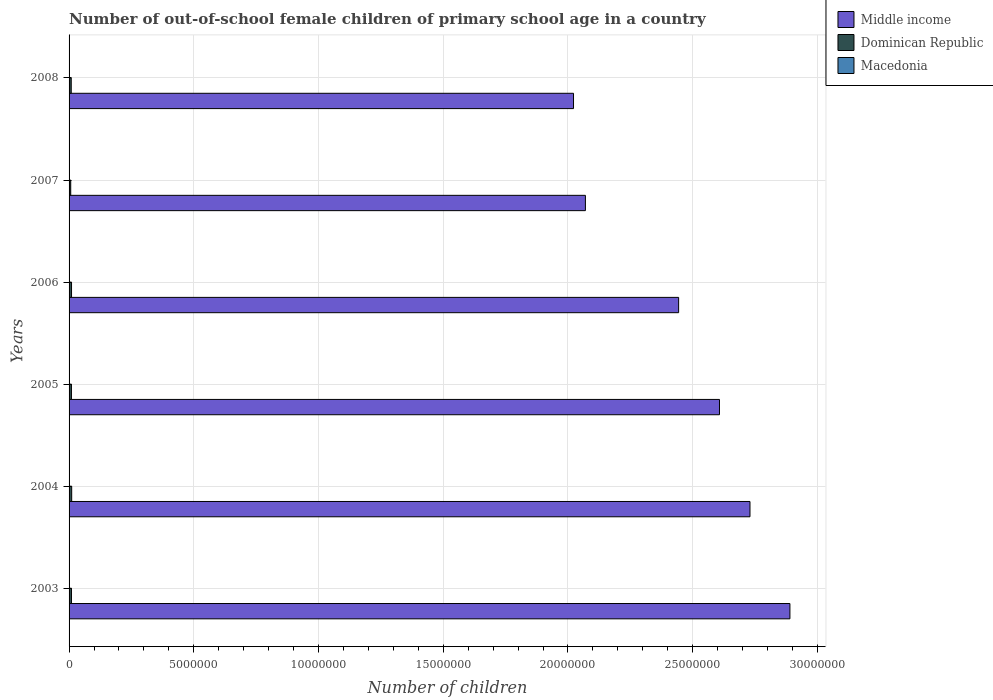How many bars are there on the 4th tick from the bottom?
Your response must be concise. 3. What is the label of the 5th group of bars from the top?
Offer a very short reply. 2004. What is the number of out-of-school female children in Middle income in 2003?
Provide a succinct answer. 2.89e+07. Across all years, what is the maximum number of out-of-school female children in Dominican Republic?
Your answer should be compact. 1.05e+05. Across all years, what is the minimum number of out-of-school female children in Dominican Republic?
Provide a short and direct response. 6.61e+04. In which year was the number of out-of-school female children in Middle income maximum?
Provide a succinct answer. 2003. What is the total number of out-of-school female children in Macedonia in the graph?
Offer a very short reply. 2.68e+04. What is the difference between the number of out-of-school female children in Dominican Republic in 2006 and that in 2008?
Your answer should be very brief. 1.19e+04. What is the difference between the number of out-of-school female children in Dominican Republic in 2006 and the number of out-of-school female children in Macedonia in 2007?
Offer a terse response. 9.52e+04. What is the average number of out-of-school female children in Middle income per year?
Provide a succinct answer. 2.46e+07. In the year 2004, what is the difference between the number of out-of-school female children in Macedonia and number of out-of-school female children in Middle income?
Offer a terse response. -2.73e+07. In how many years, is the number of out-of-school female children in Macedonia greater than 10000000 ?
Offer a terse response. 0. What is the ratio of the number of out-of-school female children in Dominican Republic in 2006 to that in 2007?
Keep it short and to the point. 1.5. Is the number of out-of-school female children in Dominican Republic in 2004 less than that in 2008?
Make the answer very short. No. What is the difference between the highest and the second highest number of out-of-school female children in Dominican Republic?
Your response must be concise. 6275. What is the difference between the highest and the lowest number of out-of-school female children in Dominican Republic?
Provide a succinct answer. 3.90e+04. In how many years, is the number of out-of-school female children in Middle income greater than the average number of out-of-school female children in Middle income taken over all years?
Provide a short and direct response. 3. Is the sum of the number of out-of-school female children in Dominican Republic in 2004 and 2007 greater than the maximum number of out-of-school female children in Macedonia across all years?
Your answer should be compact. Yes. What does the 1st bar from the top in 2008 represents?
Keep it short and to the point. Macedonia. What does the 2nd bar from the bottom in 2005 represents?
Offer a terse response. Dominican Republic. Does the graph contain grids?
Provide a succinct answer. Yes. How many legend labels are there?
Keep it short and to the point. 3. What is the title of the graph?
Provide a succinct answer. Number of out-of-school female children of primary school age in a country. Does "Tajikistan" appear as one of the legend labels in the graph?
Your answer should be compact. No. What is the label or title of the X-axis?
Ensure brevity in your answer.  Number of children. What is the Number of children of Middle income in 2003?
Give a very brief answer. 2.89e+07. What is the Number of children in Dominican Republic in 2003?
Make the answer very short. 9.59e+04. What is the Number of children of Macedonia in 2003?
Offer a very short reply. 5669. What is the Number of children of Middle income in 2004?
Keep it short and to the point. 2.73e+07. What is the Number of children in Dominican Republic in 2004?
Keep it short and to the point. 1.05e+05. What is the Number of children in Macedonia in 2004?
Your answer should be compact. 5037. What is the Number of children of Middle income in 2005?
Offer a very short reply. 2.61e+07. What is the Number of children of Dominican Republic in 2005?
Your answer should be very brief. 9.47e+04. What is the Number of children in Macedonia in 2005?
Provide a succinct answer. 4294. What is the Number of children of Middle income in 2006?
Provide a short and direct response. 2.44e+07. What is the Number of children of Dominican Republic in 2006?
Make the answer very short. 9.88e+04. What is the Number of children in Macedonia in 2006?
Give a very brief answer. 4150. What is the Number of children of Middle income in 2007?
Your response must be concise. 2.07e+07. What is the Number of children in Dominican Republic in 2007?
Give a very brief answer. 6.61e+04. What is the Number of children in Macedonia in 2007?
Your answer should be very brief. 3682. What is the Number of children in Middle income in 2008?
Offer a terse response. 2.02e+07. What is the Number of children of Dominican Republic in 2008?
Provide a short and direct response. 8.70e+04. What is the Number of children in Macedonia in 2008?
Ensure brevity in your answer.  3971. Across all years, what is the maximum Number of children of Middle income?
Provide a short and direct response. 2.89e+07. Across all years, what is the maximum Number of children of Dominican Republic?
Provide a succinct answer. 1.05e+05. Across all years, what is the maximum Number of children of Macedonia?
Ensure brevity in your answer.  5669. Across all years, what is the minimum Number of children of Middle income?
Keep it short and to the point. 2.02e+07. Across all years, what is the minimum Number of children of Dominican Republic?
Provide a short and direct response. 6.61e+04. Across all years, what is the minimum Number of children in Macedonia?
Your answer should be compact. 3682. What is the total Number of children of Middle income in the graph?
Your answer should be very brief. 1.48e+08. What is the total Number of children in Dominican Republic in the graph?
Your answer should be very brief. 5.48e+05. What is the total Number of children in Macedonia in the graph?
Provide a succinct answer. 2.68e+04. What is the difference between the Number of children in Middle income in 2003 and that in 2004?
Keep it short and to the point. 1.60e+06. What is the difference between the Number of children of Dominican Republic in 2003 and that in 2004?
Provide a succinct answer. -9225. What is the difference between the Number of children in Macedonia in 2003 and that in 2004?
Your answer should be compact. 632. What is the difference between the Number of children of Middle income in 2003 and that in 2005?
Give a very brief answer. 2.82e+06. What is the difference between the Number of children of Dominican Republic in 2003 and that in 2005?
Ensure brevity in your answer.  1151. What is the difference between the Number of children in Macedonia in 2003 and that in 2005?
Give a very brief answer. 1375. What is the difference between the Number of children in Middle income in 2003 and that in 2006?
Provide a short and direct response. 4.46e+06. What is the difference between the Number of children of Dominican Republic in 2003 and that in 2006?
Your response must be concise. -2950. What is the difference between the Number of children of Macedonia in 2003 and that in 2006?
Provide a succinct answer. 1519. What is the difference between the Number of children in Middle income in 2003 and that in 2007?
Your answer should be very brief. 8.20e+06. What is the difference between the Number of children of Dominican Republic in 2003 and that in 2007?
Make the answer very short. 2.98e+04. What is the difference between the Number of children in Macedonia in 2003 and that in 2007?
Provide a succinct answer. 1987. What is the difference between the Number of children of Middle income in 2003 and that in 2008?
Your answer should be compact. 8.67e+06. What is the difference between the Number of children in Dominican Republic in 2003 and that in 2008?
Keep it short and to the point. 8920. What is the difference between the Number of children of Macedonia in 2003 and that in 2008?
Offer a very short reply. 1698. What is the difference between the Number of children in Middle income in 2004 and that in 2005?
Your response must be concise. 1.22e+06. What is the difference between the Number of children in Dominican Republic in 2004 and that in 2005?
Offer a terse response. 1.04e+04. What is the difference between the Number of children of Macedonia in 2004 and that in 2005?
Offer a terse response. 743. What is the difference between the Number of children in Middle income in 2004 and that in 2006?
Your answer should be very brief. 2.86e+06. What is the difference between the Number of children of Dominican Republic in 2004 and that in 2006?
Provide a short and direct response. 6275. What is the difference between the Number of children in Macedonia in 2004 and that in 2006?
Your answer should be very brief. 887. What is the difference between the Number of children of Middle income in 2004 and that in 2007?
Give a very brief answer. 6.60e+06. What is the difference between the Number of children in Dominican Republic in 2004 and that in 2007?
Offer a terse response. 3.90e+04. What is the difference between the Number of children of Macedonia in 2004 and that in 2007?
Make the answer very short. 1355. What is the difference between the Number of children of Middle income in 2004 and that in 2008?
Ensure brevity in your answer.  7.07e+06. What is the difference between the Number of children of Dominican Republic in 2004 and that in 2008?
Your answer should be compact. 1.81e+04. What is the difference between the Number of children in Macedonia in 2004 and that in 2008?
Your answer should be compact. 1066. What is the difference between the Number of children in Middle income in 2005 and that in 2006?
Offer a very short reply. 1.64e+06. What is the difference between the Number of children of Dominican Republic in 2005 and that in 2006?
Offer a terse response. -4101. What is the difference between the Number of children in Macedonia in 2005 and that in 2006?
Your answer should be compact. 144. What is the difference between the Number of children of Middle income in 2005 and that in 2007?
Provide a succinct answer. 5.38e+06. What is the difference between the Number of children of Dominican Republic in 2005 and that in 2007?
Offer a very short reply. 2.87e+04. What is the difference between the Number of children in Macedonia in 2005 and that in 2007?
Offer a very short reply. 612. What is the difference between the Number of children of Middle income in 2005 and that in 2008?
Keep it short and to the point. 5.85e+06. What is the difference between the Number of children in Dominican Republic in 2005 and that in 2008?
Provide a short and direct response. 7769. What is the difference between the Number of children in Macedonia in 2005 and that in 2008?
Provide a short and direct response. 323. What is the difference between the Number of children in Middle income in 2006 and that in 2007?
Your response must be concise. 3.74e+06. What is the difference between the Number of children in Dominican Republic in 2006 and that in 2007?
Offer a terse response. 3.28e+04. What is the difference between the Number of children in Macedonia in 2006 and that in 2007?
Provide a short and direct response. 468. What is the difference between the Number of children in Middle income in 2006 and that in 2008?
Give a very brief answer. 4.21e+06. What is the difference between the Number of children in Dominican Republic in 2006 and that in 2008?
Your answer should be very brief. 1.19e+04. What is the difference between the Number of children of Macedonia in 2006 and that in 2008?
Offer a very short reply. 179. What is the difference between the Number of children in Middle income in 2007 and that in 2008?
Offer a terse response. 4.77e+05. What is the difference between the Number of children of Dominican Republic in 2007 and that in 2008?
Provide a succinct answer. -2.09e+04. What is the difference between the Number of children of Macedonia in 2007 and that in 2008?
Provide a short and direct response. -289. What is the difference between the Number of children in Middle income in 2003 and the Number of children in Dominican Republic in 2004?
Provide a succinct answer. 2.88e+07. What is the difference between the Number of children in Middle income in 2003 and the Number of children in Macedonia in 2004?
Provide a succinct answer. 2.89e+07. What is the difference between the Number of children in Dominican Republic in 2003 and the Number of children in Macedonia in 2004?
Give a very brief answer. 9.09e+04. What is the difference between the Number of children in Middle income in 2003 and the Number of children in Dominican Republic in 2005?
Ensure brevity in your answer.  2.88e+07. What is the difference between the Number of children of Middle income in 2003 and the Number of children of Macedonia in 2005?
Offer a terse response. 2.89e+07. What is the difference between the Number of children of Dominican Republic in 2003 and the Number of children of Macedonia in 2005?
Make the answer very short. 9.16e+04. What is the difference between the Number of children in Middle income in 2003 and the Number of children in Dominican Republic in 2006?
Provide a succinct answer. 2.88e+07. What is the difference between the Number of children of Middle income in 2003 and the Number of children of Macedonia in 2006?
Offer a terse response. 2.89e+07. What is the difference between the Number of children in Dominican Republic in 2003 and the Number of children in Macedonia in 2006?
Keep it short and to the point. 9.17e+04. What is the difference between the Number of children of Middle income in 2003 and the Number of children of Dominican Republic in 2007?
Your response must be concise. 2.88e+07. What is the difference between the Number of children of Middle income in 2003 and the Number of children of Macedonia in 2007?
Your response must be concise. 2.89e+07. What is the difference between the Number of children of Dominican Republic in 2003 and the Number of children of Macedonia in 2007?
Provide a succinct answer. 9.22e+04. What is the difference between the Number of children of Middle income in 2003 and the Number of children of Dominican Republic in 2008?
Keep it short and to the point. 2.88e+07. What is the difference between the Number of children in Middle income in 2003 and the Number of children in Macedonia in 2008?
Offer a very short reply. 2.89e+07. What is the difference between the Number of children of Dominican Republic in 2003 and the Number of children of Macedonia in 2008?
Offer a terse response. 9.19e+04. What is the difference between the Number of children in Middle income in 2004 and the Number of children in Dominican Republic in 2005?
Your answer should be compact. 2.72e+07. What is the difference between the Number of children of Middle income in 2004 and the Number of children of Macedonia in 2005?
Offer a terse response. 2.73e+07. What is the difference between the Number of children in Dominican Republic in 2004 and the Number of children in Macedonia in 2005?
Your answer should be very brief. 1.01e+05. What is the difference between the Number of children in Middle income in 2004 and the Number of children in Dominican Republic in 2006?
Make the answer very short. 2.72e+07. What is the difference between the Number of children of Middle income in 2004 and the Number of children of Macedonia in 2006?
Offer a very short reply. 2.73e+07. What is the difference between the Number of children in Dominican Republic in 2004 and the Number of children in Macedonia in 2006?
Provide a short and direct response. 1.01e+05. What is the difference between the Number of children in Middle income in 2004 and the Number of children in Dominican Republic in 2007?
Keep it short and to the point. 2.72e+07. What is the difference between the Number of children in Middle income in 2004 and the Number of children in Macedonia in 2007?
Your answer should be very brief. 2.73e+07. What is the difference between the Number of children in Dominican Republic in 2004 and the Number of children in Macedonia in 2007?
Your answer should be very brief. 1.01e+05. What is the difference between the Number of children in Middle income in 2004 and the Number of children in Dominican Republic in 2008?
Offer a very short reply. 2.72e+07. What is the difference between the Number of children of Middle income in 2004 and the Number of children of Macedonia in 2008?
Your response must be concise. 2.73e+07. What is the difference between the Number of children of Dominican Republic in 2004 and the Number of children of Macedonia in 2008?
Your answer should be compact. 1.01e+05. What is the difference between the Number of children of Middle income in 2005 and the Number of children of Dominican Republic in 2006?
Your answer should be very brief. 2.60e+07. What is the difference between the Number of children in Middle income in 2005 and the Number of children in Macedonia in 2006?
Your answer should be very brief. 2.61e+07. What is the difference between the Number of children in Dominican Republic in 2005 and the Number of children in Macedonia in 2006?
Ensure brevity in your answer.  9.06e+04. What is the difference between the Number of children of Middle income in 2005 and the Number of children of Dominican Republic in 2007?
Offer a terse response. 2.60e+07. What is the difference between the Number of children in Middle income in 2005 and the Number of children in Macedonia in 2007?
Provide a succinct answer. 2.61e+07. What is the difference between the Number of children in Dominican Republic in 2005 and the Number of children in Macedonia in 2007?
Provide a short and direct response. 9.11e+04. What is the difference between the Number of children in Middle income in 2005 and the Number of children in Dominican Republic in 2008?
Your answer should be very brief. 2.60e+07. What is the difference between the Number of children of Middle income in 2005 and the Number of children of Macedonia in 2008?
Your answer should be compact. 2.61e+07. What is the difference between the Number of children of Dominican Republic in 2005 and the Number of children of Macedonia in 2008?
Keep it short and to the point. 9.08e+04. What is the difference between the Number of children in Middle income in 2006 and the Number of children in Dominican Republic in 2007?
Your answer should be very brief. 2.44e+07. What is the difference between the Number of children of Middle income in 2006 and the Number of children of Macedonia in 2007?
Ensure brevity in your answer.  2.44e+07. What is the difference between the Number of children of Dominican Republic in 2006 and the Number of children of Macedonia in 2007?
Provide a succinct answer. 9.52e+04. What is the difference between the Number of children of Middle income in 2006 and the Number of children of Dominican Republic in 2008?
Make the answer very short. 2.43e+07. What is the difference between the Number of children of Middle income in 2006 and the Number of children of Macedonia in 2008?
Make the answer very short. 2.44e+07. What is the difference between the Number of children of Dominican Republic in 2006 and the Number of children of Macedonia in 2008?
Offer a terse response. 9.49e+04. What is the difference between the Number of children in Middle income in 2007 and the Number of children in Dominican Republic in 2008?
Ensure brevity in your answer.  2.06e+07. What is the difference between the Number of children of Middle income in 2007 and the Number of children of Macedonia in 2008?
Offer a very short reply. 2.07e+07. What is the difference between the Number of children of Dominican Republic in 2007 and the Number of children of Macedonia in 2008?
Your answer should be compact. 6.21e+04. What is the average Number of children in Middle income per year?
Your answer should be compact. 2.46e+07. What is the average Number of children in Dominican Republic per year?
Ensure brevity in your answer.  9.13e+04. What is the average Number of children in Macedonia per year?
Keep it short and to the point. 4467.17. In the year 2003, what is the difference between the Number of children in Middle income and Number of children in Dominican Republic?
Provide a short and direct response. 2.88e+07. In the year 2003, what is the difference between the Number of children in Middle income and Number of children in Macedonia?
Give a very brief answer. 2.89e+07. In the year 2003, what is the difference between the Number of children in Dominican Republic and Number of children in Macedonia?
Provide a short and direct response. 9.02e+04. In the year 2004, what is the difference between the Number of children in Middle income and Number of children in Dominican Republic?
Your answer should be compact. 2.72e+07. In the year 2004, what is the difference between the Number of children in Middle income and Number of children in Macedonia?
Your answer should be compact. 2.73e+07. In the year 2004, what is the difference between the Number of children in Dominican Republic and Number of children in Macedonia?
Your answer should be compact. 1.00e+05. In the year 2005, what is the difference between the Number of children in Middle income and Number of children in Dominican Republic?
Ensure brevity in your answer.  2.60e+07. In the year 2005, what is the difference between the Number of children in Middle income and Number of children in Macedonia?
Your answer should be very brief. 2.61e+07. In the year 2005, what is the difference between the Number of children of Dominican Republic and Number of children of Macedonia?
Offer a very short reply. 9.04e+04. In the year 2006, what is the difference between the Number of children in Middle income and Number of children in Dominican Republic?
Offer a very short reply. 2.43e+07. In the year 2006, what is the difference between the Number of children of Middle income and Number of children of Macedonia?
Provide a short and direct response. 2.44e+07. In the year 2006, what is the difference between the Number of children in Dominican Republic and Number of children in Macedonia?
Your response must be concise. 9.47e+04. In the year 2007, what is the difference between the Number of children in Middle income and Number of children in Dominican Republic?
Your response must be concise. 2.06e+07. In the year 2007, what is the difference between the Number of children in Middle income and Number of children in Macedonia?
Give a very brief answer. 2.07e+07. In the year 2007, what is the difference between the Number of children in Dominican Republic and Number of children in Macedonia?
Provide a short and direct response. 6.24e+04. In the year 2008, what is the difference between the Number of children in Middle income and Number of children in Dominican Republic?
Offer a terse response. 2.01e+07. In the year 2008, what is the difference between the Number of children of Middle income and Number of children of Macedonia?
Make the answer very short. 2.02e+07. In the year 2008, what is the difference between the Number of children of Dominican Republic and Number of children of Macedonia?
Provide a short and direct response. 8.30e+04. What is the ratio of the Number of children of Middle income in 2003 to that in 2004?
Your answer should be compact. 1.06. What is the ratio of the Number of children of Dominican Republic in 2003 to that in 2004?
Your answer should be very brief. 0.91. What is the ratio of the Number of children of Macedonia in 2003 to that in 2004?
Make the answer very short. 1.13. What is the ratio of the Number of children of Middle income in 2003 to that in 2005?
Offer a very short reply. 1.11. What is the ratio of the Number of children of Dominican Republic in 2003 to that in 2005?
Offer a terse response. 1.01. What is the ratio of the Number of children in Macedonia in 2003 to that in 2005?
Make the answer very short. 1.32. What is the ratio of the Number of children in Middle income in 2003 to that in 2006?
Your answer should be very brief. 1.18. What is the ratio of the Number of children in Dominican Republic in 2003 to that in 2006?
Give a very brief answer. 0.97. What is the ratio of the Number of children in Macedonia in 2003 to that in 2006?
Make the answer very short. 1.37. What is the ratio of the Number of children of Middle income in 2003 to that in 2007?
Your response must be concise. 1.4. What is the ratio of the Number of children of Dominican Republic in 2003 to that in 2007?
Make the answer very short. 1.45. What is the ratio of the Number of children of Macedonia in 2003 to that in 2007?
Your answer should be compact. 1.54. What is the ratio of the Number of children in Middle income in 2003 to that in 2008?
Give a very brief answer. 1.43. What is the ratio of the Number of children of Dominican Republic in 2003 to that in 2008?
Keep it short and to the point. 1.1. What is the ratio of the Number of children in Macedonia in 2003 to that in 2008?
Ensure brevity in your answer.  1.43. What is the ratio of the Number of children in Middle income in 2004 to that in 2005?
Your answer should be compact. 1.05. What is the ratio of the Number of children of Dominican Republic in 2004 to that in 2005?
Make the answer very short. 1.11. What is the ratio of the Number of children of Macedonia in 2004 to that in 2005?
Make the answer very short. 1.17. What is the ratio of the Number of children of Middle income in 2004 to that in 2006?
Provide a succinct answer. 1.12. What is the ratio of the Number of children of Dominican Republic in 2004 to that in 2006?
Your answer should be very brief. 1.06. What is the ratio of the Number of children of Macedonia in 2004 to that in 2006?
Offer a terse response. 1.21. What is the ratio of the Number of children of Middle income in 2004 to that in 2007?
Give a very brief answer. 1.32. What is the ratio of the Number of children in Dominican Republic in 2004 to that in 2007?
Offer a terse response. 1.59. What is the ratio of the Number of children of Macedonia in 2004 to that in 2007?
Your response must be concise. 1.37. What is the ratio of the Number of children of Middle income in 2004 to that in 2008?
Your response must be concise. 1.35. What is the ratio of the Number of children of Dominican Republic in 2004 to that in 2008?
Keep it short and to the point. 1.21. What is the ratio of the Number of children of Macedonia in 2004 to that in 2008?
Keep it short and to the point. 1.27. What is the ratio of the Number of children of Middle income in 2005 to that in 2006?
Offer a very short reply. 1.07. What is the ratio of the Number of children of Dominican Republic in 2005 to that in 2006?
Your answer should be very brief. 0.96. What is the ratio of the Number of children of Macedonia in 2005 to that in 2006?
Provide a short and direct response. 1.03. What is the ratio of the Number of children in Middle income in 2005 to that in 2007?
Offer a terse response. 1.26. What is the ratio of the Number of children in Dominican Republic in 2005 to that in 2007?
Give a very brief answer. 1.43. What is the ratio of the Number of children in Macedonia in 2005 to that in 2007?
Give a very brief answer. 1.17. What is the ratio of the Number of children in Middle income in 2005 to that in 2008?
Your response must be concise. 1.29. What is the ratio of the Number of children of Dominican Republic in 2005 to that in 2008?
Offer a very short reply. 1.09. What is the ratio of the Number of children of Macedonia in 2005 to that in 2008?
Give a very brief answer. 1.08. What is the ratio of the Number of children in Middle income in 2006 to that in 2007?
Offer a very short reply. 1.18. What is the ratio of the Number of children of Dominican Republic in 2006 to that in 2007?
Give a very brief answer. 1.5. What is the ratio of the Number of children of Macedonia in 2006 to that in 2007?
Your answer should be very brief. 1.13. What is the ratio of the Number of children of Middle income in 2006 to that in 2008?
Your answer should be very brief. 1.21. What is the ratio of the Number of children of Dominican Republic in 2006 to that in 2008?
Offer a very short reply. 1.14. What is the ratio of the Number of children in Macedonia in 2006 to that in 2008?
Provide a succinct answer. 1.05. What is the ratio of the Number of children in Middle income in 2007 to that in 2008?
Provide a succinct answer. 1.02. What is the ratio of the Number of children in Dominican Republic in 2007 to that in 2008?
Your answer should be very brief. 0.76. What is the ratio of the Number of children in Macedonia in 2007 to that in 2008?
Ensure brevity in your answer.  0.93. What is the difference between the highest and the second highest Number of children of Middle income?
Provide a short and direct response. 1.60e+06. What is the difference between the highest and the second highest Number of children in Dominican Republic?
Give a very brief answer. 6275. What is the difference between the highest and the second highest Number of children of Macedonia?
Your response must be concise. 632. What is the difference between the highest and the lowest Number of children in Middle income?
Give a very brief answer. 8.67e+06. What is the difference between the highest and the lowest Number of children in Dominican Republic?
Ensure brevity in your answer.  3.90e+04. What is the difference between the highest and the lowest Number of children of Macedonia?
Provide a succinct answer. 1987. 